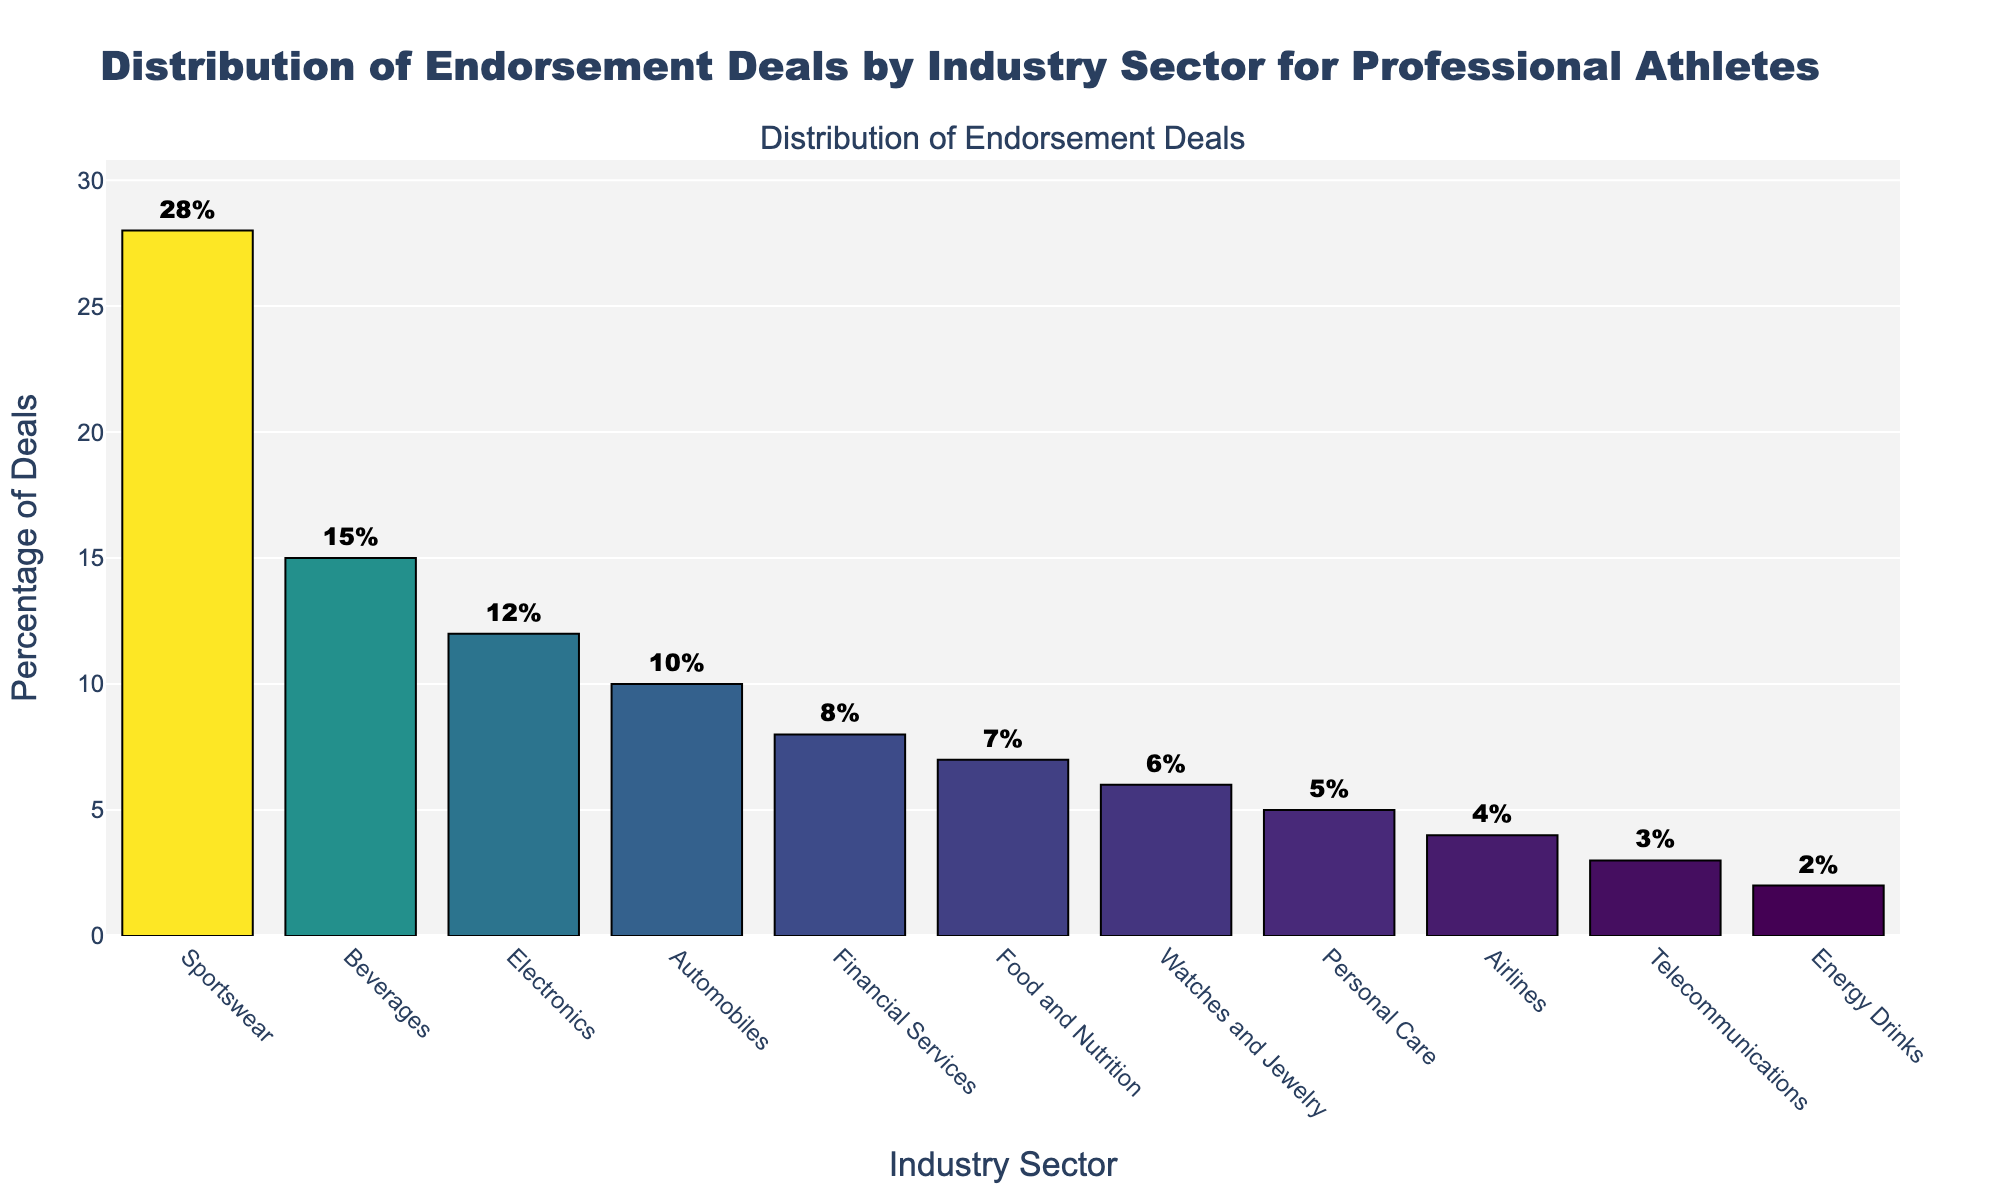Which industry has the highest percentage of endorsement deals? By visually inspecting the heights of the bars, the "Sportswear" industry has the highest bar, indicating the highest percentage.
Answer: Sportswear Which two sectors combined make up more than one-third of the endorsement deals? Adding the percentages of "Sportswear" (28%) and "Beverages" (15%), we get 43%. Since 43% is more than one-third (33.33%), these two sectors combined make up more than one-third of the deals.
Answer: Sportswear and Beverages Which industry has the smallest percentage of endorsement deals? By looking at the shortest bar in the chart, we see that the "Energy Drinks" industry has the smallest percentage.
Answer: Energy Drinks Are Food and Nutrition endorsement deals more or less common than Financial Services? By comparing the heights of the bars for "Food and Nutrition" (7%) and "Financial Services" (8%), "Food and Nutrition" has a shorter bar, indicating fewer deals.
Answer: Less common What is the combined percentage of endorsement deals in the Electronics, Personal Care, and Watches and Jewelry sectors? Adding the percentages of "Electronics" (12%), "Personal Care" (5%), and "Watches and Jewelry" (6%) gives us a total of 23%.
Answer: 23% How much more common are Sportswear endorsements compared to Automobiles endorsements? Subtract the percentage of "Automobiles" (10%) from "Sportswear" (28%) to get the difference. So, 28% - 10% = 18%.
Answer: 18% Which three sectors have percentages that are equal to or less than 5%? By checking the height of the bars, "Personal Care" (5%), "Airlines" (4%), "Telecommunications" (3%), and "Energy Drinks" (2%) all have percentages equal to or less than 5%. There are actually four sectors but the question asks only for three.
Answer: Personal Care, Airlines, and Telecommunications What is the average percentage of endorsement deals across all sectors? Sum all percentages (28 + 15 + 12 + 10 + 8 + 7 + 6 + 5 + 4 + 3 + 2 = 100). There are 11 sectors, so the average is 100 / 11 ≈ 9.09%.
Answer: 9.09% Which sector’s percentage of deals is closest to the overall average? The overall average is approximately 9.09%. The sector with the percentage closest to this value is "Financial Services" at 8%.
Answer: Financial Services 